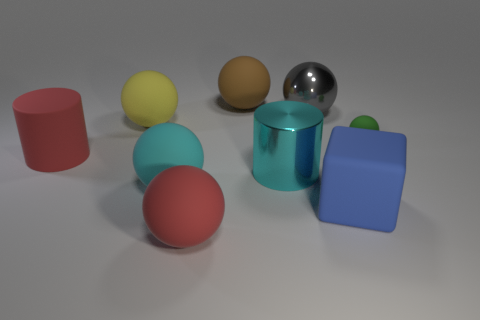Subtract all cyan balls. How many balls are left? 5 Subtract all yellow spheres. How many spheres are left? 5 Subtract all red balls. Subtract all yellow cylinders. How many balls are left? 5 Subtract all spheres. How many objects are left? 3 Add 4 shiny balls. How many shiny balls are left? 5 Add 9 yellow rubber objects. How many yellow rubber objects exist? 10 Subtract 1 blue cubes. How many objects are left? 8 Subtract all small yellow metal objects. Subtract all red rubber things. How many objects are left? 7 